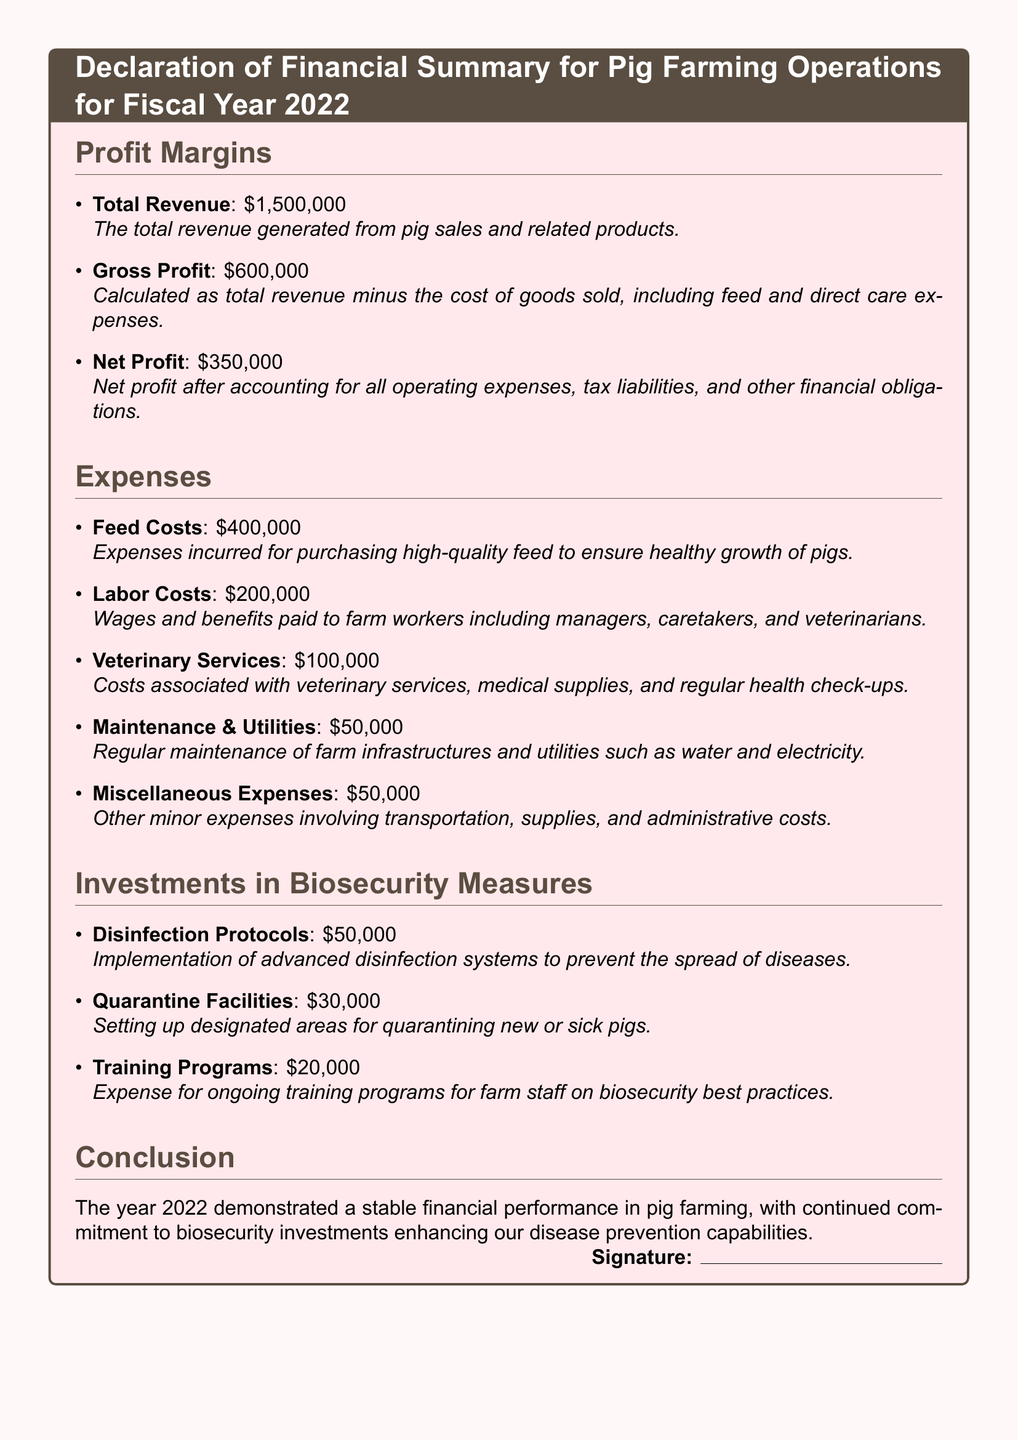What is the total revenue? The total revenue is listed as $1,500,000, which comes from pig sales and related products.
Answer: $1,500,000 What is the net profit for the fiscal year 2022? The net profit is calculated after accounting for all operating expenses, which is stated as $350,000.
Answer: $350,000 How much was spent on feed costs? The document states that feed costs incurred were $400,000 for purchasing high-quality feed.
Answer: $400,000 What were the expenses for veterinary services? The costs associated with veterinary services are explicitly mentioned as $100,000 in the document.
Answer: $100,000 What is the total investment in biosecurity measures? To find the total investment, we sum the amounts from each biosecurity measure listed in the document, totaling $100,000.
Answer: $100,000 How much was allocated for training programs? The document notes that $20,000 was spent on ongoing training programs for farm staff on biosecurity best practices.
Answer: $20,000 Which expense category had the highest cost? By comparing the expenses, labor costs of $200,000 are noted as the highest in the document.
Answer: Labor Costs What is the purpose of quarantine facilities? The document states that quarantine facilities were set up for isolating new or sick pigs, thus preventing disease spread.
Answer: Isolating new or sick pigs What is the conclusion of the financial summary? The conclusion emphasizes stable financial performance, particularly through investments in biosecurity.
Answer: Stable financial performance 